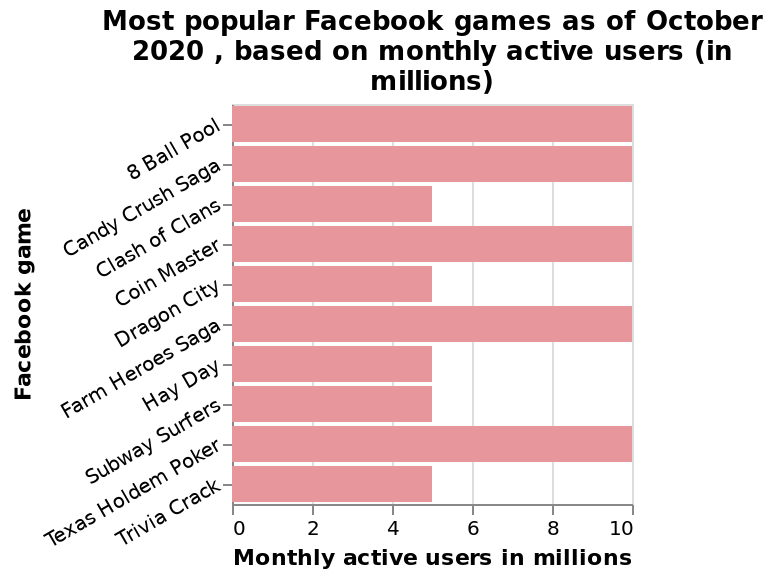<image>
What is the lowest rated Facebook game as of October 2020? The lowest rated Facebook game as of October 2020 is 8 Ball Pool. Which Facebook game has the highest monthly active users in millions? The Facebook game with the highest monthly active users in millions is Trivia Crack. What were the popular Facebook games as of October 2020 based on monthly active users? Candy Crush Saga, 8 Ball Pool, Coin masters, farm here saga, and Texas holdem poker. 